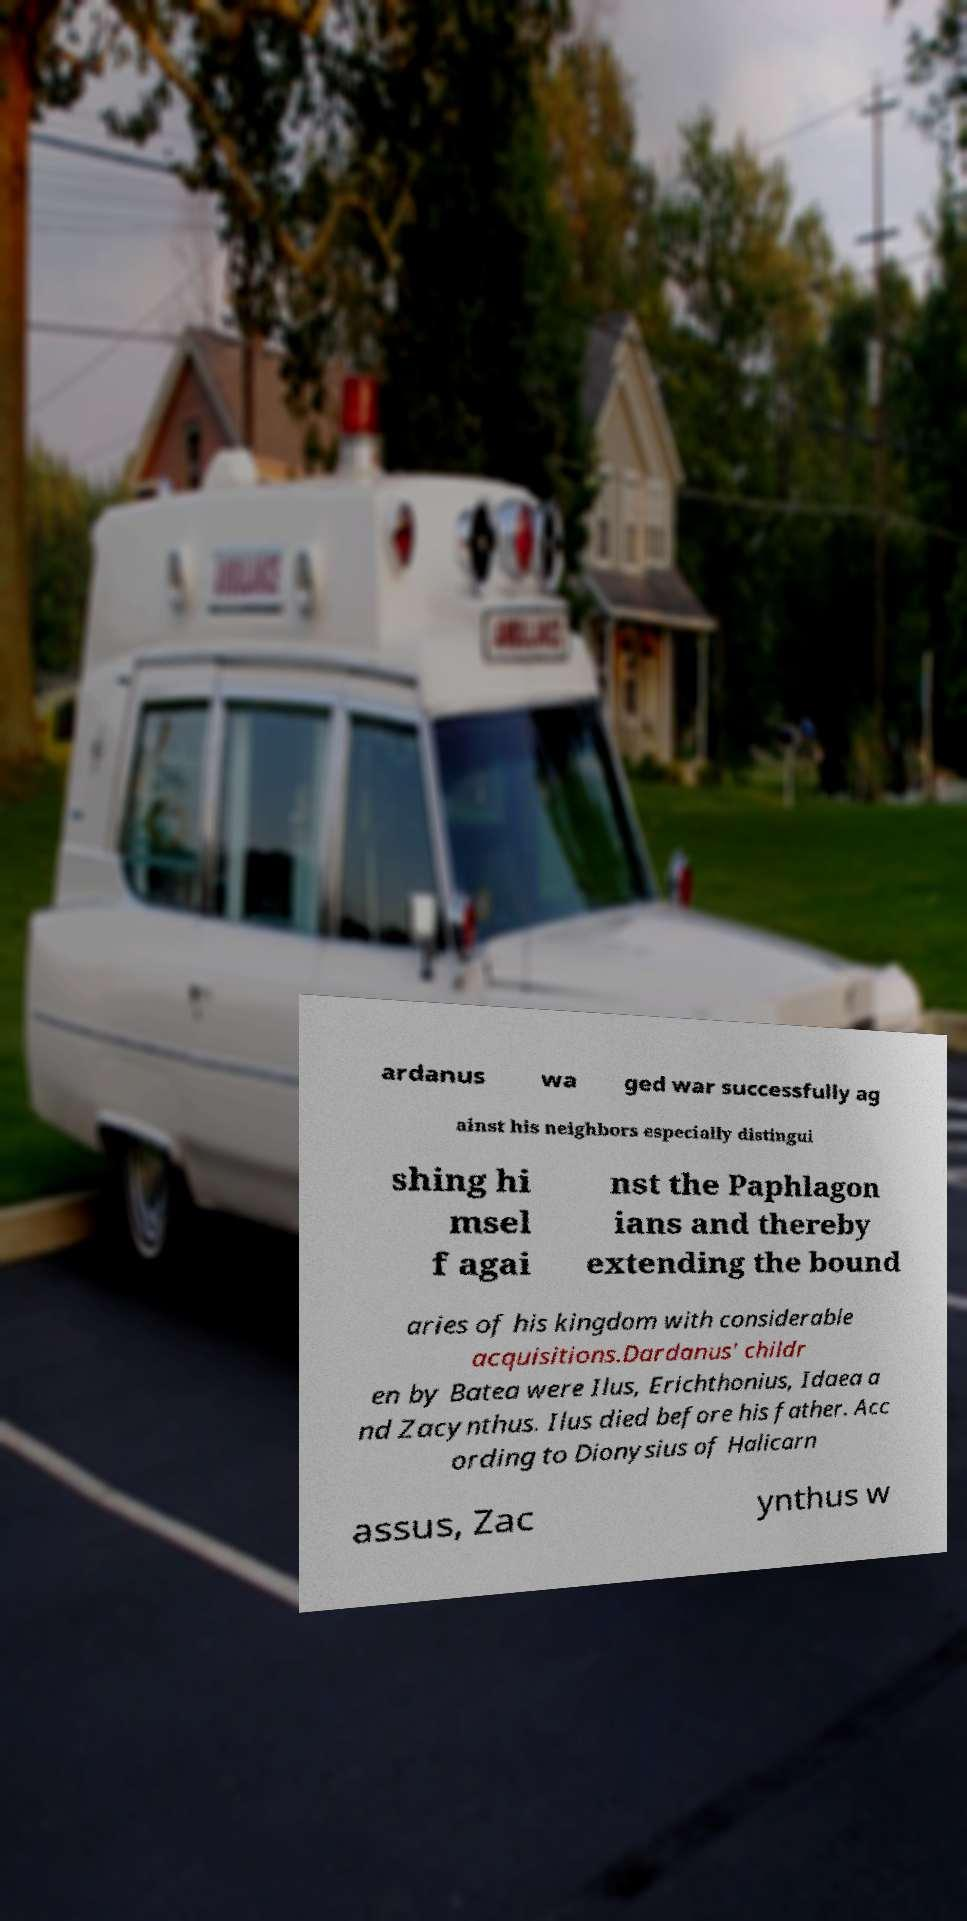Please identify and transcribe the text found in this image. ardanus wa ged war successfully ag ainst his neighbors especially distingui shing hi msel f agai nst the Paphlagon ians and thereby extending the bound aries of his kingdom with considerable acquisitions.Dardanus' childr en by Batea were Ilus, Erichthonius, Idaea a nd Zacynthus. Ilus died before his father. Acc ording to Dionysius of Halicarn assus, Zac ynthus w 